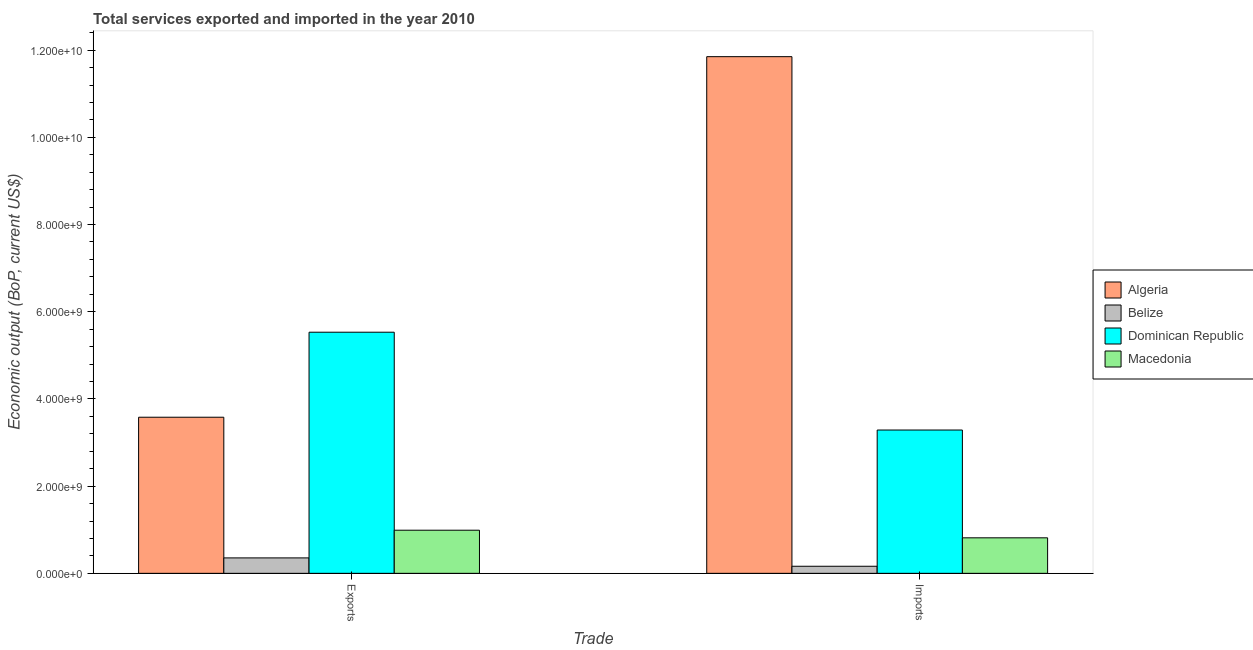How many different coloured bars are there?
Your answer should be compact. 4. How many groups of bars are there?
Offer a terse response. 2. Are the number of bars per tick equal to the number of legend labels?
Offer a terse response. Yes. What is the label of the 1st group of bars from the left?
Keep it short and to the point. Exports. What is the amount of service exports in Algeria?
Provide a succinct answer. 3.58e+09. Across all countries, what is the maximum amount of service exports?
Your response must be concise. 5.53e+09. Across all countries, what is the minimum amount of service exports?
Offer a terse response. 3.54e+08. In which country was the amount of service exports maximum?
Provide a succinct answer. Dominican Republic. In which country was the amount of service exports minimum?
Keep it short and to the point. Belize. What is the total amount of service imports in the graph?
Ensure brevity in your answer.  1.61e+1. What is the difference between the amount of service exports in Algeria and that in Dominican Republic?
Keep it short and to the point. -1.95e+09. What is the difference between the amount of service exports in Belize and the amount of service imports in Macedonia?
Offer a very short reply. -4.61e+08. What is the average amount of service imports per country?
Keep it short and to the point. 4.03e+09. What is the difference between the amount of service exports and amount of service imports in Dominican Republic?
Provide a succinct answer. 2.24e+09. What is the ratio of the amount of service exports in Dominican Republic to that in Belize?
Your answer should be compact. 15.63. What does the 4th bar from the left in Exports represents?
Offer a terse response. Macedonia. What does the 2nd bar from the right in Imports represents?
Ensure brevity in your answer.  Dominican Republic. How many bars are there?
Keep it short and to the point. 8. How many countries are there in the graph?
Provide a short and direct response. 4. Does the graph contain any zero values?
Give a very brief answer. No. Where does the legend appear in the graph?
Your response must be concise. Center right. How many legend labels are there?
Give a very brief answer. 4. What is the title of the graph?
Offer a very short reply. Total services exported and imported in the year 2010. What is the label or title of the X-axis?
Offer a very short reply. Trade. What is the label or title of the Y-axis?
Your answer should be very brief. Economic output (BoP, current US$). What is the Economic output (BoP, current US$) in Algeria in Exports?
Your answer should be compact. 3.58e+09. What is the Economic output (BoP, current US$) of Belize in Exports?
Provide a short and direct response. 3.54e+08. What is the Economic output (BoP, current US$) of Dominican Republic in Exports?
Provide a short and direct response. 5.53e+09. What is the Economic output (BoP, current US$) in Macedonia in Exports?
Provide a succinct answer. 9.89e+08. What is the Economic output (BoP, current US$) in Algeria in Imports?
Keep it short and to the point. 1.19e+1. What is the Economic output (BoP, current US$) in Belize in Imports?
Make the answer very short. 1.62e+08. What is the Economic output (BoP, current US$) of Dominican Republic in Imports?
Offer a terse response. 3.29e+09. What is the Economic output (BoP, current US$) of Macedonia in Imports?
Your answer should be very brief. 8.14e+08. Across all Trade, what is the maximum Economic output (BoP, current US$) of Algeria?
Your response must be concise. 1.19e+1. Across all Trade, what is the maximum Economic output (BoP, current US$) in Belize?
Provide a short and direct response. 3.54e+08. Across all Trade, what is the maximum Economic output (BoP, current US$) of Dominican Republic?
Offer a terse response. 5.53e+09. Across all Trade, what is the maximum Economic output (BoP, current US$) of Macedonia?
Make the answer very short. 9.89e+08. Across all Trade, what is the minimum Economic output (BoP, current US$) in Algeria?
Your response must be concise. 3.58e+09. Across all Trade, what is the minimum Economic output (BoP, current US$) in Belize?
Give a very brief answer. 1.62e+08. Across all Trade, what is the minimum Economic output (BoP, current US$) of Dominican Republic?
Give a very brief answer. 3.29e+09. Across all Trade, what is the minimum Economic output (BoP, current US$) in Macedonia?
Provide a succinct answer. 8.14e+08. What is the total Economic output (BoP, current US$) in Algeria in the graph?
Offer a very short reply. 1.54e+1. What is the total Economic output (BoP, current US$) of Belize in the graph?
Offer a very short reply. 5.16e+08. What is the total Economic output (BoP, current US$) in Dominican Republic in the graph?
Provide a succinct answer. 8.82e+09. What is the total Economic output (BoP, current US$) of Macedonia in the graph?
Offer a very short reply. 1.80e+09. What is the difference between the Economic output (BoP, current US$) of Algeria in Exports and that in Imports?
Provide a succinct answer. -8.27e+09. What is the difference between the Economic output (BoP, current US$) of Belize in Exports and that in Imports?
Your answer should be compact. 1.91e+08. What is the difference between the Economic output (BoP, current US$) of Dominican Republic in Exports and that in Imports?
Your response must be concise. 2.24e+09. What is the difference between the Economic output (BoP, current US$) of Macedonia in Exports and that in Imports?
Your response must be concise. 1.75e+08. What is the difference between the Economic output (BoP, current US$) in Algeria in Exports and the Economic output (BoP, current US$) in Belize in Imports?
Your answer should be compact. 3.42e+09. What is the difference between the Economic output (BoP, current US$) in Algeria in Exports and the Economic output (BoP, current US$) in Dominican Republic in Imports?
Keep it short and to the point. 2.94e+08. What is the difference between the Economic output (BoP, current US$) in Algeria in Exports and the Economic output (BoP, current US$) in Macedonia in Imports?
Provide a short and direct response. 2.77e+09. What is the difference between the Economic output (BoP, current US$) in Belize in Exports and the Economic output (BoP, current US$) in Dominican Republic in Imports?
Offer a terse response. -2.93e+09. What is the difference between the Economic output (BoP, current US$) in Belize in Exports and the Economic output (BoP, current US$) in Macedonia in Imports?
Make the answer very short. -4.61e+08. What is the difference between the Economic output (BoP, current US$) in Dominican Republic in Exports and the Economic output (BoP, current US$) in Macedonia in Imports?
Your response must be concise. 4.72e+09. What is the average Economic output (BoP, current US$) of Algeria per Trade?
Offer a terse response. 7.72e+09. What is the average Economic output (BoP, current US$) of Belize per Trade?
Offer a terse response. 2.58e+08. What is the average Economic output (BoP, current US$) in Dominican Republic per Trade?
Provide a short and direct response. 4.41e+09. What is the average Economic output (BoP, current US$) in Macedonia per Trade?
Offer a terse response. 9.02e+08. What is the difference between the Economic output (BoP, current US$) in Algeria and Economic output (BoP, current US$) in Belize in Exports?
Your answer should be compact. 3.23e+09. What is the difference between the Economic output (BoP, current US$) in Algeria and Economic output (BoP, current US$) in Dominican Republic in Exports?
Give a very brief answer. -1.95e+09. What is the difference between the Economic output (BoP, current US$) in Algeria and Economic output (BoP, current US$) in Macedonia in Exports?
Your answer should be very brief. 2.59e+09. What is the difference between the Economic output (BoP, current US$) in Belize and Economic output (BoP, current US$) in Dominican Republic in Exports?
Offer a very short reply. -5.18e+09. What is the difference between the Economic output (BoP, current US$) of Belize and Economic output (BoP, current US$) of Macedonia in Exports?
Give a very brief answer. -6.35e+08. What is the difference between the Economic output (BoP, current US$) of Dominican Republic and Economic output (BoP, current US$) of Macedonia in Exports?
Provide a short and direct response. 4.54e+09. What is the difference between the Economic output (BoP, current US$) of Algeria and Economic output (BoP, current US$) of Belize in Imports?
Keep it short and to the point. 1.17e+1. What is the difference between the Economic output (BoP, current US$) of Algeria and Economic output (BoP, current US$) of Dominican Republic in Imports?
Your response must be concise. 8.56e+09. What is the difference between the Economic output (BoP, current US$) of Algeria and Economic output (BoP, current US$) of Macedonia in Imports?
Provide a succinct answer. 1.10e+1. What is the difference between the Economic output (BoP, current US$) in Belize and Economic output (BoP, current US$) in Dominican Republic in Imports?
Make the answer very short. -3.12e+09. What is the difference between the Economic output (BoP, current US$) in Belize and Economic output (BoP, current US$) in Macedonia in Imports?
Your answer should be compact. -6.52e+08. What is the difference between the Economic output (BoP, current US$) in Dominican Republic and Economic output (BoP, current US$) in Macedonia in Imports?
Offer a very short reply. 2.47e+09. What is the ratio of the Economic output (BoP, current US$) of Algeria in Exports to that in Imports?
Make the answer very short. 0.3. What is the ratio of the Economic output (BoP, current US$) of Belize in Exports to that in Imports?
Make the answer very short. 2.18. What is the ratio of the Economic output (BoP, current US$) of Dominican Republic in Exports to that in Imports?
Your answer should be very brief. 1.68. What is the ratio of the Economic output (BoP, current US$) of Macedonia in Exports to that in Imports?
Keep it short and to the point. 1.21. What is the difference between the highest and the second highest Economic output (BoP, current US$) of Algeria?
Provide a short and direct response. 8.27e+09. What is the difference between the highest and the second highest Economic output (BoP, current US$) in Belize?
Offer a very short reply. 1.91e+08. What is the difference between the highest and the second highest Economic output (BoP, current US$) of Dominican Republic?
Give a very brief answer. 2.24e+09. What is the difference between the highest and the second highest Economic output (BoP, current US$) of Macedonia?
Offer a very short reply. 1.75e+08. What is the difference between the highest and the lowest Economic output (BoP, current US$) in Algeria?
Provide a succinct answer. 8.27e+09. What is the difference between the highest and the lowest Economic output (BoP, current US$) in Belize?
Provide a succinct answer. 1.91e+08. What is the difference between the highest and the lowest Economic output (BoP, current US$) of Dominican Republic?
Your answer should be very brief. 2.24e+09. What is the difference between the highest and the lowest Economic output (BoP, current US$) in Macedonia?
Provide a succinct answer. 1.75e+08. 